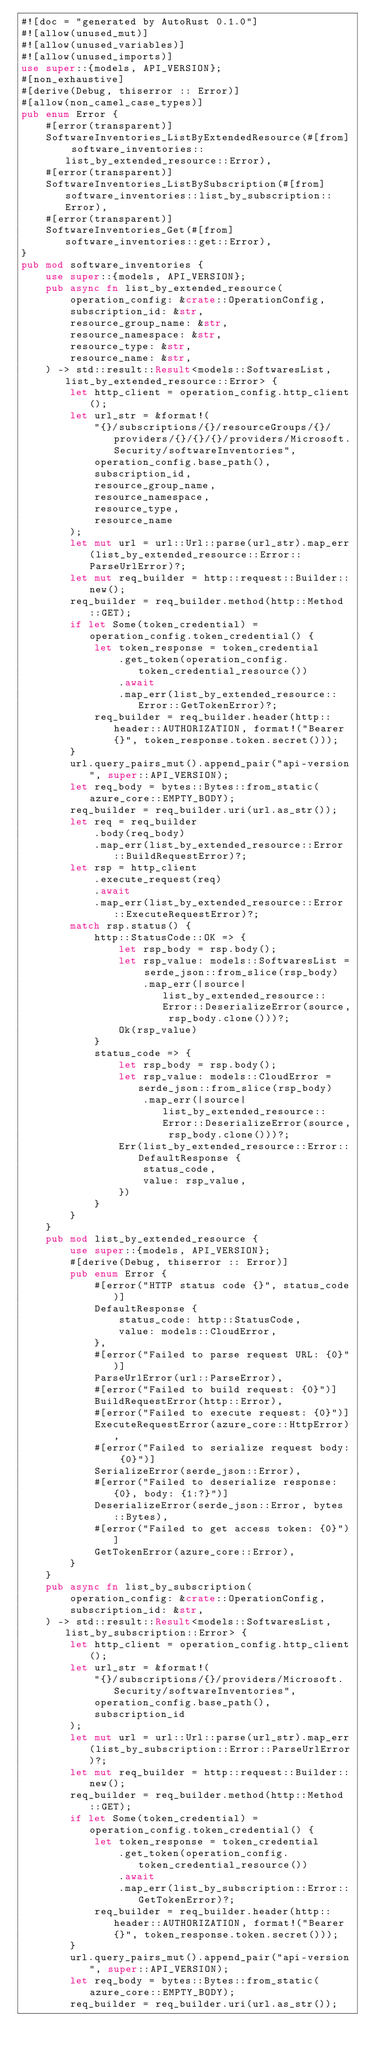Convert code to text. <code><loc_0><loc_0><loc_500><loc_500><_Rust_>#![doc = "generated by AutoRust 0.1.0"]
#![allow(unused_mut)]
#![allow(unused_variables)]
#![allow(unused_imports)]
use super::{models, API_VERSION};
#[non_exhaustive]
#[derive(Debug, thiserror :: Error)]
#[allow(non_camel_case_types)]
pub enum Error {
    #[error(transparent)]
    SoftwareInventories_ListByExtendedResource(#[from] software_inventories::list_by_extended_resource::Error),
    #[error(transparent)]
    SoftwareInventories_ListBySubscription(#[from] software_inventories::list_by_subscription::Error),
    #[error(transparent)]
    SoftwareInventories_Get(#[from] software_inventories::get::Error),
}
pub mod software_inventories {
    use super::{models, API_VERSION};
    pub async fn list_by_extended_resource(
        operation_config: &crate::OperationConfig,
        subscription_id: &str,
        resource_group_name: &str,
        resource_namespace: &str,
        resource_type: &str,
        resource_name: &str,
    ) -> std::result::Result<models::SoftwaresList, list_by_extended_resource::Error> {
        let http_client = operation_config.http_client();
        let url_str = &format!(
            "{}/subscriptions/{}/resourceGroups/{}/providers/{}/{}/{}/providers/Microsoft.Security/softwareInventories",
            operation_config.base_path(),
            subscription_id,
            resource_group_name,
            resource_namespace,
            resource_type,
            resource_name
        );
        let mut url = url::Url::parse(url_str).map_err(list_by_extended_resource::Error::ParseUrlError)?;
        let mut req_builder = http::request::Builder::new();
        req_builder = req_builder.method(http::Method::GET);
        if let Some(token_credential) = operation_config.token_credential() {
            let token_response = token_credential
                .get_token(operation_config.token_credential_resource())
                .await
                .map_err(list_by_extended_resource::Error::GetTokenError)?;
            req_builder = req_builder.header(http::header::AUTHORIZATION, format!("Bearer {}", token_response.token.secret()));
        }
        url.query_pairs_mut().append_pair("api-version", super::API_VERSION);
        let req_body = bytes::Bytes::from_static(azure_core::EMPTY_BODY);
        req_builder = req_builder.uri(url.as_str());
        let req = req_builder
            .body(req_body)
            .map_err(list_by_extended_resource::Error::BuildRequestError)?;
        let rsp = http_client
            .execute_request(req)
            .await
            .map_err(list_by_extended_resource::Error::ExecuteRequestError)?;
        match rsp.status() {
            http::StatusCode::OK => {
                let rsp_body = rsp.body();
                let rsp_value: models::SoftwaresList = serde_json::from_slice(rsp_body)
                    .map_err(|source| list_by_extended_resource::Error::DeserializeError(source, rsp_body.clone()))?;
                Ok(rsp_value)
            }
            status_code => {
                let rsp_body = rsp.body();
                let rsp_value: models::CloudError = serde_json::from_slice(rsp_body)
                    .map_err(|source| list_by_extended_resource::Error::DeserializeError(source, rsp_body.clone()))?;
                Err(list_by_extended_resource::Error::DefaultResponse {
                    status_code,
                    value: rsp_value,
                })
            }
        }
    }
    pub mod list_by_extended_resource {
        use super::{models, API_VERSION};
        #[derive(Debug, thiserror :: Error)]
        pub enum Error {
            #[error("HTTP status code {}", status_code)]
            DefaultResponse {
                status_code: http::StatusCode,
                value: models::CloudError,
            },
            #[error("Failed to parse request URL: {0}")]
            ParseUrlError(url::ParseError),
            #[error("Failed to build request: {0}")]
            BuildRequestError(http::Error),
            #[error("Failed to execute request: {0}")]
            ExecuteRequestError(azure_core::HttpError),
            #[error("Failed to serialize request body: {0}")]
            SerializeError(serde_json::Error),
            #[error("Failed to deserialize response: {0}, body: {1:?}")]
            DeserializeError(serde_json::Error, bytes::Bytes),
            #[error("Failed to get access token: {0}")]
            GetTokenError(azure_core::Error),
        }
    }
    pub async fn list_by_subscription(
        operation_config: &crate::OperationConfig,
        subscription_id: &str,
    ) -> std::result::Result<models::SoftwaresList, list_by_subscription::Error> {
        let http_client = operation_config.http_client();
        let url_str = &format!(
            "{}/subscriptions/{}/providers/Microsoft.Security/softwareInventories",
            operation_config.base_path(),
            subscription_id
        );
        let mut url = url::Url::parse(url_str).map_err(list_by_subscription::Error::ParseUrlError)?;
        let mut req_builder = http::request::Builder::new();
        req_builder = req_builder.method(http::Method::GET);
        if let Some(token_credential) = operation_config.token_credential() {
            let token_response = token_credential
                .get_token(operation_config.token_credential_resource())
                .await
                .map_err(list_by_subscription::Error::GetTokenError)?;
            req_builder = req_builder.header(http::header::AUTHORIZATION, format!("Bearer {}", token_response.token.secret()));
        }
        url.query_pairs_mut().append_pair("api-version", super::API_VERSION);
        let req_body = bytes::Bytes::from_static(azure_core::EMPTY_BODY);
        req_builder = req_builder.uri(url.as_str());</code> 